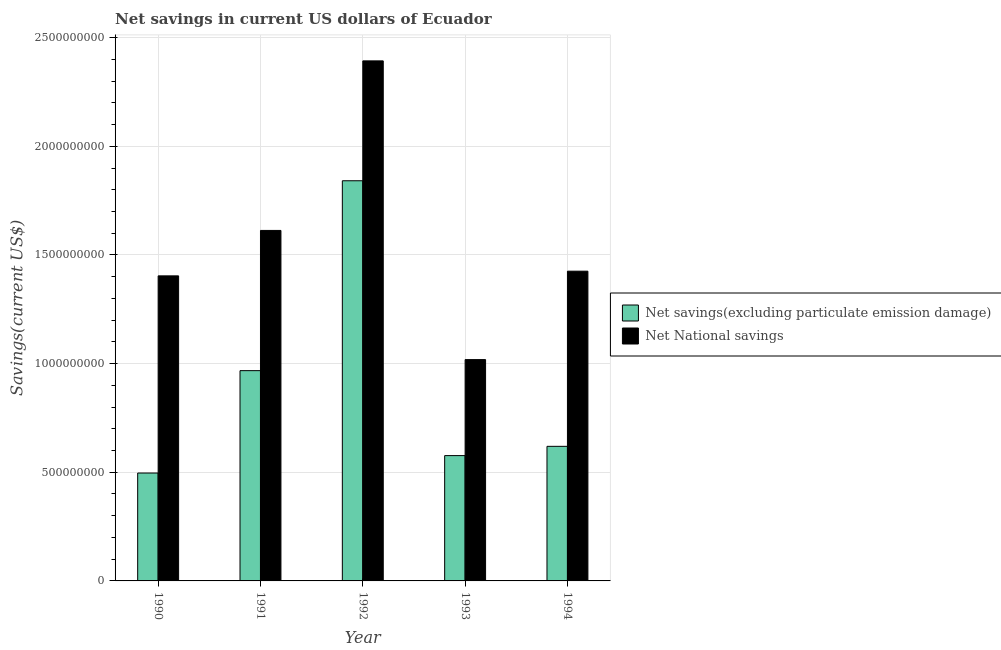How many groups of bars are there?
Keep it short and to the point. 5. Are the number of bars on each tick of the X-axis equal?
Offer a very short reply. Yes. How many bars are there on the 1st tick from the left?
Ensure brevity in your answer.  2. How many bars are there on the 1st tick from the right?
Provide a short and direct response. 2. What is the label of the 4th group of bars from the left?
Your response must be concise. 1993. In how many cases, is the number of bars for a given year not equal to the number of legend labels?
Your answer should be very brief. 0. What is the net national savings in 1991?
Keep it short and to the point. 1.61e+09. Across all years, what is the maximum net national savings?
Your answer should be very brief. 2.39e+09. Across all years, what is the minimum net national savings?
Provide a short and direct response. 1.02e+09. In which year was the net savings(excluding particulate emission damage) minimum?
Offer a very short reply. 1990. What is the total net national savings in the graph?
Keep it short and to the point. 7.85e+09. What is the difference between the net savings(excluding particulate emission damage) in 1992 and that in 1993?
Keep it short and to the point. 1.26e+09. What is the difference between the net savings(excluding particulate emission damage) in 1994 and the net national savings in 1991?
Keep it short and to the point. -3.48e+08. What is the average net savings(excluding particulate emission damage) per year?
Provide a succinct answer. 9.00e+08. What is the ratio of the net savings(excluding particulate emission damage) in 1990 to that in 1991?
Ensure brevity in your answer.  0.51. Is the difference between the net savings(excluding particulate emission damage) in 1992 and 1993 greater than the difference between the net national savings in 1992 and 1993?
Keep it short and to the point. No. What is the difference between the highest and the second highest net national savings?
Your answer should be very brief. 7.80e+08. What is the difference between the highest and the lowest net savings(excluding particulate emission damage)?
Ensure brevity in your answer.  1.34e+09. In how many years, is the net savings(excluding particulate emission damage) greater than the average net savings(excluding particulate emission damage) taken over all years?
Provide a succinct answer. 2. Is the sum of the net national savings in 1990 and 1994 greater than the maximum net savings(excluding particulate emission damage) across all years?
Your answer should be very brief. Yes. What does the 2nd bar from the left in 1993 represents?
Give a very brief answer. Net National savings. What does the 1st bar from the right in 1991 represents?
Give a very brief answer. Net National savings. How many years are there in the graph?
Your answer should be very brief. 5. Does the graph contain any zero values?
Provide a short and direct response. No. How are the legend labels stacked?
Offer a terse response. Vertical. What is the title of the graph?
Provide a short and direct response. Net savings in current US dollars of Ecuador. Does "Working only" appear as one of the legend labels in the graph?
Give a very brief answer. No. What is the label or title of the X-axis?
Provide a succinct answer. Year. What is the label or title of the Y-axis?
Your answer should be compact. Savings(current US$). What is the Savings(current US$) of Net savings(excluding particulate emission damage) in 1990?
Your answer should be very brief. 4.97e+08. What is the Savings(current US$) of Net National savings in 1990?
Offer a very short reply. 1.40e+09. What is the Savings(current US$) in Net savings(excluding particulate emission damage) in 1991?
Your answer should be very brief. 9.68e+08. What is the Savings(current US$) of Net National savings in 1991?
Offer a terse response. 1.61e+09. What is the Savings(current US$) in Net savings(excluding particulate emission damage) in 1992?
Your response must be concise. 1.84e+09. What is the Savings(current US$) of Net National savings in 1992?
Keep it short and to the point. 2.39e+09. What is the Savings(current US$) in Net savings(excluding particulate emission damage) in 1993?
Keep it short and to the point. 5.77e+08. What is the Savings(current US$) of Net National savings in 1993?
Ensure brevity in your answer.  1.02e+09. What is the Savings(current US$) of Net savings(excluding particulate emission damage) in 1994?
Your answer should be very brief. 6.19e+08. What is the Savings(current US$) in Net National savings in 1994?
Keep it short and to the point. 1.43e+09. Across all years, what is the maximum Savings(current US$) of Net savings(excluding particulate emission damage)?
Offer a terse response. 1.84e+09. Across all years, what is the maximum Savings(current US$) of Net National savings?
Make the answer very short. 2.39e+09. Across all years, what is the minimum Savings(current US$) of Net savings(excluding particulate emission damage)?
Offer a terse response. 4.97e+08. Across all years, what is the minimum Savings(current US$) in Net National savings?
Offer a very short reply. 1.02e+09. What is the total Savings(current US$) in Net savings(excluding particulate emission damage) in the graph?
Provide a short and direct response. 4.50e+09. What is the total Savings(current US$) of Net National savings in the graph?
Offer a terse response. 7.85e+09. What is the difference between the Savings(current US$) of Net savings(excluding particulate emission damage) in 1990 and that in 1991?
Provide a short and direct response. -4.71e+08. What is the difference between the Savings(current US$) of Net National savings in 1990 and that in 1991?
Your answer should be compact. -2.09e+08. What is the difference between the Savings(current US$) of Net savings(excluding particulate emission damage) in 1990 and that in 1992?
Your answer should be compact. -1.34e+09. What is the difference between the Savings(current US$) of Net National savings in 1990 and that in 1992?
Make the answer very short. -9.89e+08. What is the difference between the Savings(current US$) in Net savings(excluding particulate emission damage) in 1990 and that in 1993?
Your answer should be compact. -8.02e+07. What is the difference between the Savings(current US$) in Net National savings in 1990 and that in 1993?
Keep it short and to the point. 3.85e+08. What is the difference between the Savings(current US$) in Net savings(excluding particulate emission damage) in 1990 and that in 1994?
Your answer should be compact. -1.23e+08. What is the difference between the Savings(current US$) in Net National savings in 1990 and that in 1994?
Your answer should be very brief. -2.16e+07. What is the difference between the Savings(current US$) in Net savings(excluding particulate emission damage) in 1991 and that in 1992?
Provide a succinct answer. -8.74e+08. What is the difference between the Savings(current US$) of Net National savings in 1991 and that in 1992?
Give a very brief answer. -7.80e+08. What is the difference between the Savings(current US$) in Net savings(excluding particulate emission damage) in 1991 and that in 1993?
Offer a terse response. 3.91e+08. What is the difference between the Savings(current US$) of Net National savings in 1991 and that in 1993?
Your answer should be compact. 5.94e+08. What is the difference between the Savings(current US$) in Net savings(excluding particulate emission damage) in 1991 and that in 1994?
Your answer should be compact. 3.48e+08. What is the difference between the Savings(current US$) of Net National savings in 1991 and that in 1994?
Your answer should be very brief. 1.87e+08. What is the difference between the Savings(current US$) in Net savings(excluding particulate emission damage) in 1992 and that in 1993?
Your response must be concise. 1.26e+09. What is the difference between the Savings(current US$) of Net National savings in 1992 and that in 1993?
Your response must be concise. 1.37e+09. What is the difference between the Savings(current US$) of Net savings(excluding particulate emission damage) in 1992 and that in 1994?
Make the answer very short. 1.22e+09. What is the difference between the Savings(current US$) of Net National savings in 1992 and that in 1994?
Your answer should be compact. 9.68e+08. What is the difference between the Savings(current US$) in Net savings(excluding particulate emission damage) in 1993 and that in 1994?
Make the answer very short. -4.26e+07. What is the difference between the Savings(current US$) of Net National savings in 1993 and that in 1994?
Offer a very short reply. -4.07e+08. What is the difference between the Savings(current US$) of Net savings(excluding particulate emission damage) in 1990 and the Savings(current US$) of Net National savings in 1991?
Your answer should be very brief. -1.12e+09. What is the difference between the Savings(current US$) of Net savings(excluding particulate emission damage) in 1990 and the Savings(current US$) of Net National savings in 1992?
Your answer should be compact. -1.90e+09. What is the difference between the Savings(current US$) of Net savings(excluding particulate emission damage) in 1990 and the Savings(current US$) of Net National savings in 1993?
Keep it short and to the point. -5.22e+08. What is the difference between the Savings(current US$) in Net savings(excluding particulate emission damage) in 1990 and the Savings(current US$) in Net National savings in 1994?
Ensure brevity in your answer.  -9.29e+08. What is the difference between the Savings(current US$) of Net savings(excluding particulate emission damage) in 1991 and the Savings(current US$) of Net National savings in 1992?
Give a very brief answer. -1.43e+09. What is the difference between the Savings(current US$) in Net savings(excluding particulate emission damage) in 1991 and the Savings(current US$) in Net National savings in 1993?
Your response must be concise. -5.08e+07. What is the difference between the Savings(current US$) of Net savings(excluding particulate emission damage) in 1991 and the Savings(current US$) of Net National savings in 1994?
Your answer should be compact. -4.58e+08. What is the difference between the Savings(current US$) of Net savings(excluding particulate emission damage) in 1992 and the Savings(current US$) of Net National savings in 1993?
Offer a very short reply. 8.23e+08. What is the difference between the Savings(current US$) of Net savings(excluding particulate emission damage) in 1992 and the Savings(current US$) of Net National savings in 1994?
Ensure brevity in your answer.  4.16e+08. What is the difference between the Savings(current US$) of Net savings(excluding particulate emission damage) in 1993 and the Savings(current US$) of Net National savings in 1994?
Your answer should be compact. -8.49e+08. What is the average Savings(current US$) of Net savings(excluding particulate emission damage) per year?
Offer a terse response. 9.00e+08. What is the average Savings(current US$) of Net National savings per year?
Ensure brevity in your answer.  1.57e+09. In the year 1990, what is the difference between the Savings(current US$) of Net savings(excluding particulate emission damage) and Savings(current US$) of Net National savings?
Keep it short and to the point. -9.07e+08. In the year 1991, what is the difference between the Savings(current US$) in Net savings(excluding particulate emission damage) and Savings(current US$) in Net National savings?
Your response must be concise. -6.45e+08. In the year 1992, what is the difference between the Savings(current US$) of Net savings(excluding particulate emission damage) and Savings(current US$) of Net National savings?
Offer a very short reply. -5.52e+08. In the year 1993, what is the difference between the Savings(current US$) of Net savings(excluding particulate emission damage) and Savings(current US$) of Net National savings?
Keep it short and to the point. -4.42e+08. In the year 1994, what is the difference between the Savings(current US$) of Net savings(excluding particulate emission damage) and Savings(current US$) of Net National savings?
Provide a short and direct response. -8.06e+08. What is the ratio of the Savings(current US$) of Net savings(excluding particulate emission damage) in 1990 to that in 1991?
Provide a succinct answer. 0.51. What is the ratio of the Savings(current US$) of Net National savings in 1990 to that in 1991?
Give a very brief answer. 0.87. What is the ratio of the Savings(current US$) of Net savings(excluding particulate emission damage) in 1990 to that in 1992?
Your answer should be very brief. 0.27. What is the ratio of the Savings(current US$) in Net National savings in 1990 to that in 1992?
Ensure brevity in your answer.  0.59. What is the ratio of the Savings(current US$) in Net savings(excluding particulate emission damage) in 1990 to that in 1993?
Your response must be concise. 0.86. What is the ratio of the Savings(current US$) of Net National savings in 1990 to that in 1993?
Ensure brevity in your answer.  1.38. What is the ratio of the Savings(current US$) in Net savings(excluding particulate emission damage) in 1990 to that in 1994?
Provide a short and direct response. 0.8. What is the ratio of the Savings(current US$) in Net National savings in 1990 to that in 1994?
Offer a terse response. 0.98. What is the ratio of the Savings(current US$) of Net savings(excluding particulate emission damage) in 1991 to that in 1992?
Your answer should be compact. 0.53. What is the ratio of the Savings(current US$) in Net National savings in 1991 to that in 1992?
Your answer should be very brief. 0.67. What is the ratio of the Savings(current US$) of Net savings(excluding particulate emission damage) in 1991 to that in 1993?
Make the answer very short. 1.68. What is the ratio of the Savings(current US$) in Net National savings in 1991 to that in 1993?
Your response must be concise. 1.58. What is the ratio of the Savings(current US$) in Net savings(excluding particulate emission damage) in 1991 to that in 1994?
Provide a short and direct response. 1.56. What is the ratio of the Savings(current US$) in Net National savings in 1991 to that in 1994?
Your answer should be compact. 1.13. What is the ratio of the Savings(current US$) in Net savings(excluding particulate emission damage) in 1992 to that in 1993?
Give a very brief answer. 3.19. What is the ratio of the Savings(current US$) in Net National savings in 1992 to that in 1993?
Your response must be concise. 2.35. What is the ratio of the Savings(current US$) in Net savings(excluding particulate emission damage) in 1992 to that in 1994?
Give a very brief answer. 2.97. What is the ratio of the Savings(current US$) in Net National savings in 1992 to that in 1994?
Offer a very short reply. 1.68. What is the ratio of the Savings(current US$) in Net savings(excluding particulate emission damage) in 1993 to that in 1994?
Give a very brief answer. 0.93. What is the ratio of the Savings(current US$) of Net National savings in 1993 to that in 1994?
Your response must be concise. 0.71. What is the difference between the highest and the second highest Savings(current US$) of Net savings(excluding particulate emission damage)?
Your response must be concise. 8.74e+08. What is the difference between the highest and the second highest Savings(current US$) in Net National savings?
Make the answer very short. 7.80e+08. What is the difference between the highest and the lowest Savings(current US$) of Net savings(excluding particulate emission damage)?
Keep it short and to the point. 1.34e+09. What is the difference between the highest and the lowest Savings(current US$) of Net National savings?
Make the answer very short. 1.37e+09. 